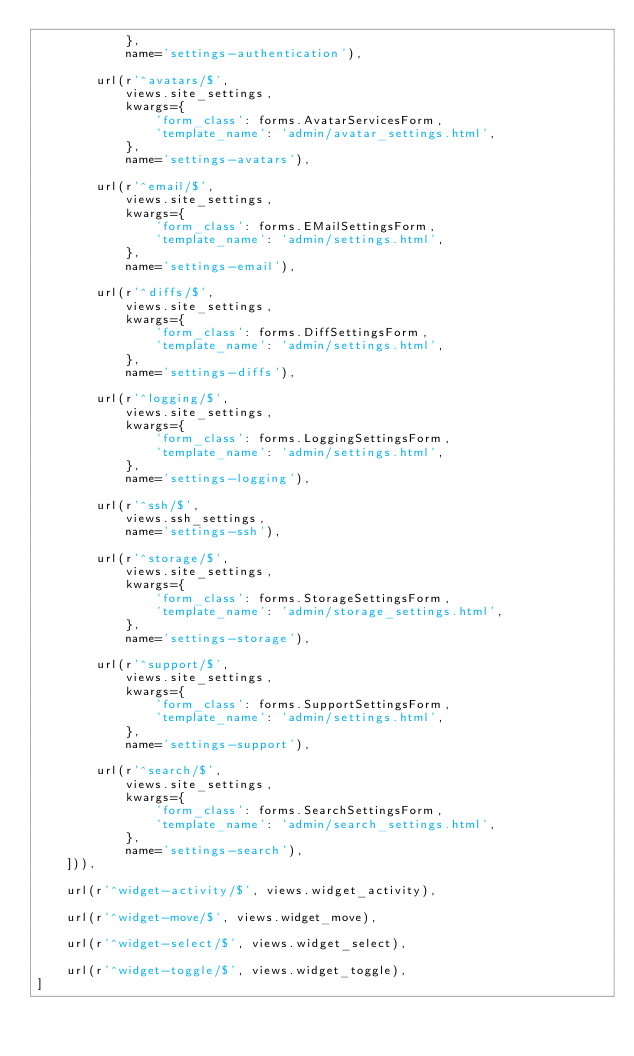<code> <loc_0><loc_0><loc_500><loc_500><_Python_>            },
            name='settings-authentication'),

        url(r'^avatars/$',
            views.site_settings,
            kwargs={
                'form_class': forms.AvatarServicesForm,
                'template_name': 'admin/avatar_settings.html',
            },
            name='settings-avatars'),

        url(r'^email/$',
            views.site_settings,
            kwargs={
                'form_class': forms.EMailSettingsForm,
                'template_name': 'admin/settings.html',
            },
            name='settings-email'),

        url(r'^diffs/$',
            views.site_settings,
            kwargs={
                'form_class': forms.DiffSettingsForm,
                'template_name': 'admin/settings.html',
            },
            name='settings-diffs'),

        url(r'^logging/$',
            views.site_settings,
            kwargs={
                'form_class': forms.LoggingSettingsForm,
                'template_name': 'admin/settings.html',
            },
            name='settings-logging'),

        url(r'^ssh/$',
            views.ssh_settings,
            name='settings-ssh'),

        url(r'^storage/$',
            views.site_settings,
            kwargs={
                'form_class': forms.StorageSettingsForm,
                'template_name': 'admin/storage_settings.html',
            },
            name='settings-storage'),

        url(r'^support/$',
            views.site_settings,
            kwargs={
                'form_class': forms.SupportSettingsForm,
                'template_name': 'admin/settings.html',
            },
            name='settings-support'),

        url(r'^search/$',
            views.site_settings,
            kwargs={
                'form_class': forms.SearchSettingsForm,
                'template_name': 'admin/search_settings.html',
            },
            name='settings-search'),
    ])),

    url(r'^widget-activity/$', views.widget_activity),

    url(r'^widget-move/$', views.widget_move),

    url(r'^widget-select/$', views.widget_select),

    url(r'^widget-toggle/$', views.widget_toggle),
]
</code> 